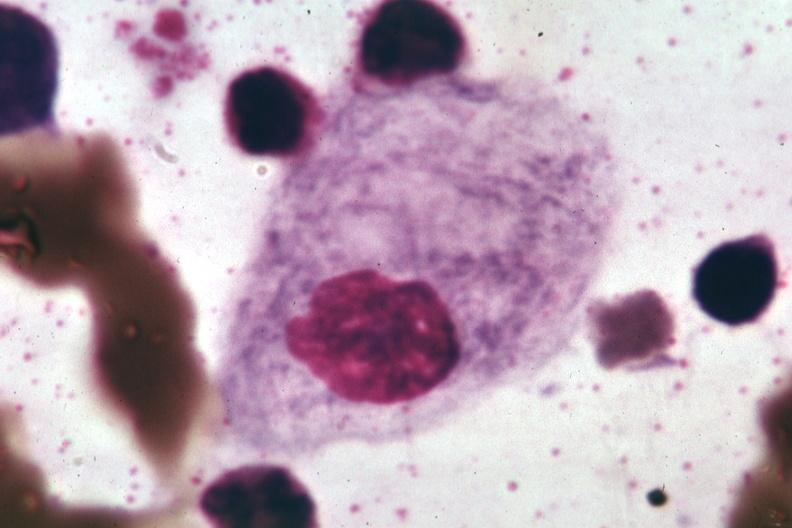s no tissue recognizable as ovary present?
Answer the question using a single word or phrase. No 